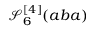<formula> <loc_0><loc_0><loc_500><loc_500>\mathcal { S } _ { 6 } ^ { [ 4 ] } ( a b a )</formula> 